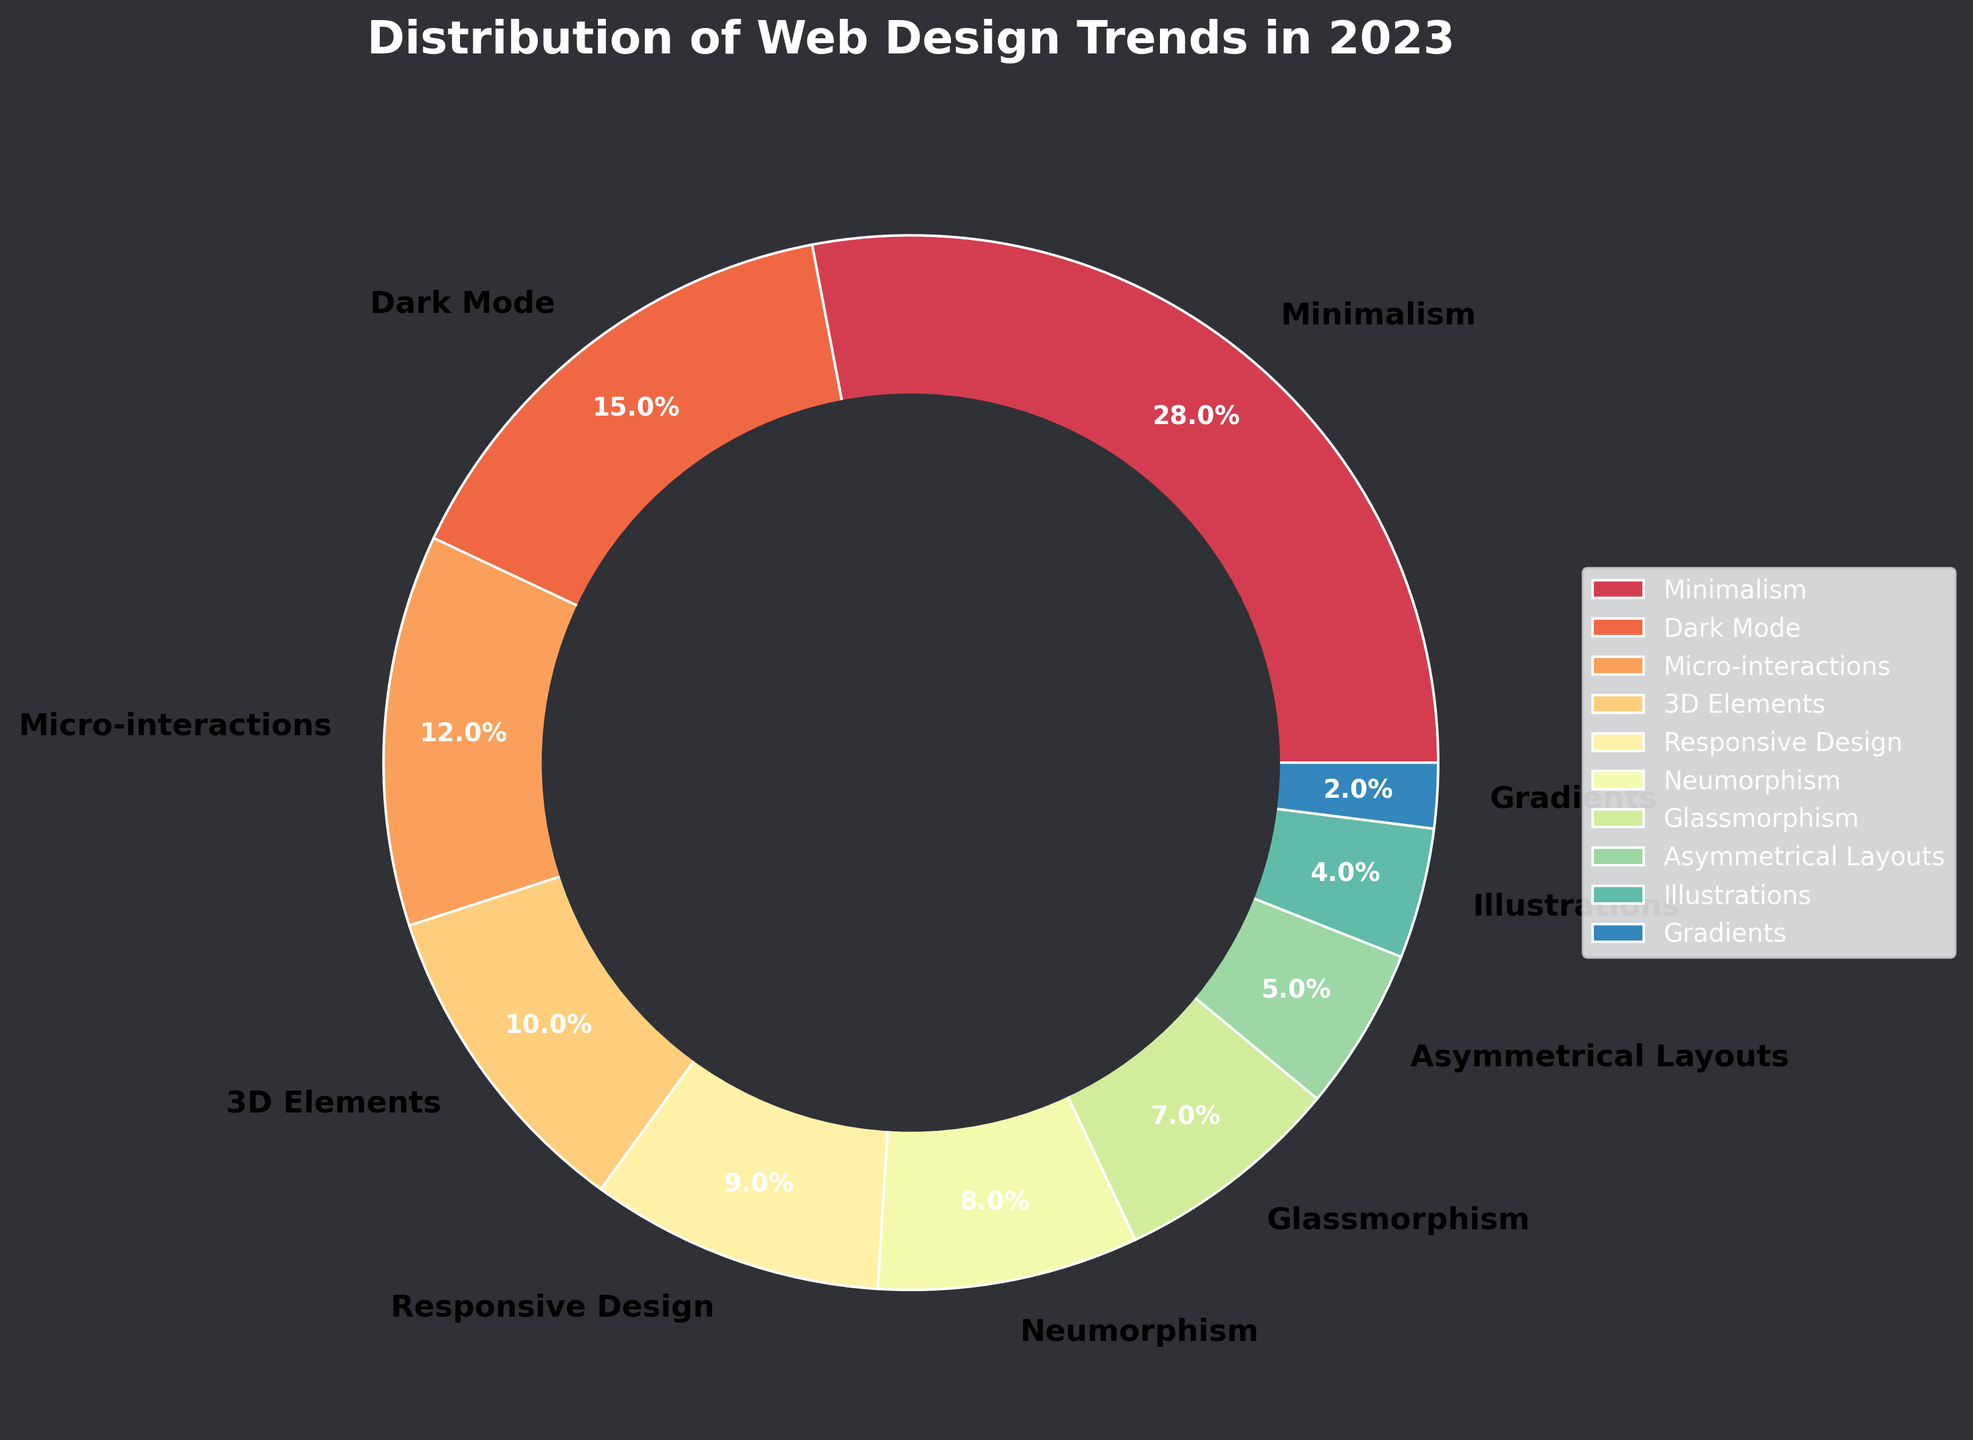What is the largest segment in the pie chart? The largest segment in the pie chart is represented by the trend with the highest percentage. By looking at the chart, we can see that Minimalism occupies the largest segment.
Answer: Minimalism How much larger is Minimalism compared to Dark Mode? To determine this, subtract the percentage of Dark Mode from the percentage of Minimalism. 28% (Minimalism) - 15% (Dark Mode) = 13%.
Answer: 13% Which trend has the smallest percentage? The trend with the smallest segment in the pie chart corresponds to the one with the smallest percentage. In this case, Gradients has the smallest segment.
Answer: Gradients What is the combined percentage of Neumorphism and Glassmorphism? To find the combined percentage, add the percentages of Neumorphism and Glassmorphism. 8% (Neumorphism) + 7% (Glassmorphism) = 15%.
Answer: 15% How do 3D Elements and Micro-interactions compare in terms of their share of the web design trends? Compare the percentages of 3D Elements and Micro-interactions. 3D Elements have a share of 10%, while Micro-interactions have a share of 12%. Thus, Micro-interactions have a larger share.
Answer: Micro-interactions have a larger share What is the total percentage of trends that are below 10%? Identify and sum the percentages of trends below 10% (Responsive Design, Neumorphism, Glassmorphism, Asymmetrical Layouts, Illustrations, Gradients). 9% + 8% + 7% + 5% + 4% + 2% = 35%.
Answer: 35% Which trends have a percentage that is at least double that of Gradients? Gradients have a percentage of 2%. Trends with at least double this percentage are those with a percentage of 4% or more. These trends are: Minimalism, Dark Mode, Micro-interactions, 3D Elements, Responsive Design, Neumorphism, Glassmorphism, and Asymmetrical Layouts.
Answer: Minimalism, Dark Mode, Micro-interactions, 3D Elements, Responsive Design, Neumorphism, Glassmorphism, Asymmetrical Layouts What does the central circle in the graph represent? The central circle visually separates the wedges and makes the pie chart appear as a donut chart. It does not represent data but is included for visual aesthetics.
Answer: Visual aesthetics Compare the sum of percentages for Minimalism, Dark Mode, and Micro-interactions to the sum of the remaining trends. First, sum the percentages for Minimalism, Dark Mode, and Micro-interactions: 28% + 15% + 12% = 55%. Next, find the total percentage for the remaining trends by subtracting 55% from 100%: 100% - 55% = 45%.
Answer: 55% vs 45% 